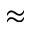Convert formula to latex. <formula><loc_0><loc_0><loc_500><loc_500>\approx</formula> 